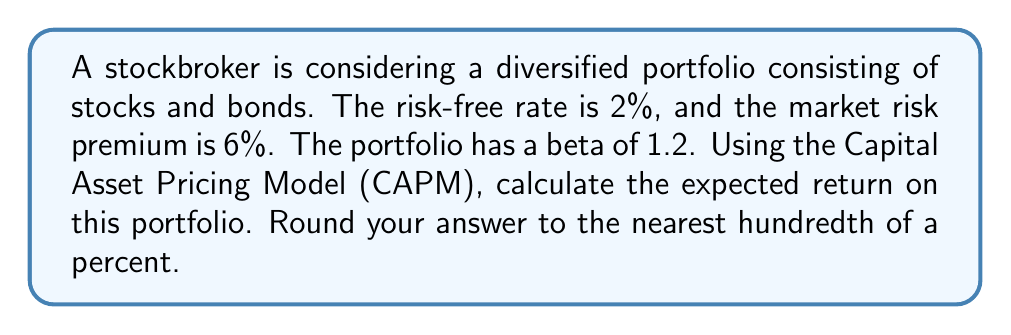Solve this math problem. To determine the expected return on the portfolio using the Capital Asset Pricing Model (CAPM), we'll follow these steps:

1. Recall the CAPM formula:
   $$E(R_p) = R_f + \beta_p(E(R_m) - R_f)$$
   Where:
   $E(R_p)$ = Expected return on the portfolio
   $R_f$ = Risk-free rate
   $\beta_p$ = Beta of the portfolio
   $E(R_m) - R_f$ = Market risk premium

2. Given information:
   $R_f = 2\%$ (Risk-free rate)
   $E(R_m) - R_f = 6\%$ (Market risk premium)
   $\beta_p = 1.2$ (Portfolio beta)

3. Substitute the values into the CAPM formula:
   $$E(R_p) = 2\% + 1.2(6\%)$$

4. Calculate:
   $$E(R_p) = 2\% + 7.2\%$$
   $$E(R_p) = 9.2\%$$

5. Round to the nearest hundredth of a percent:
   $$E(R_p) = 9.20\%$$

Thus, the expected return on the portfolio is 9.20%.
Answer: 9.20% 